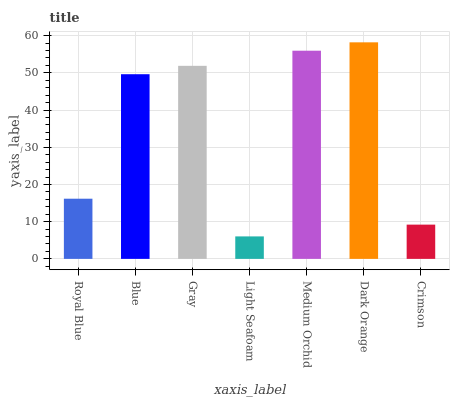Is Light Seafoam the minimum?
Answer yes or no. Yes. Is Dark Orange the maximum?
Answer yes or no. Yes. Is Blue the minimum?
Answer yes or no. No. Is Blue the maximum?
Answer yes or no. No. Is Blue greater than Royal Blue?
Answer yes or no. Yes. Is Royal Blue less than Blue?
Answer yes or no. Yes. Is Royal Blue greater than Blue?
Answer yes or no. No. Is Blue less than Royal Blue?
Answer yes or no. No. Is Blue the high median?
Answer yes or no. Yes. Is Blue the low median?
Answer yes or no. Yes. Is Royal Blue the high median?
Answer yes or no. No. Is Crimson the low median?
Answer yes or no. No. 